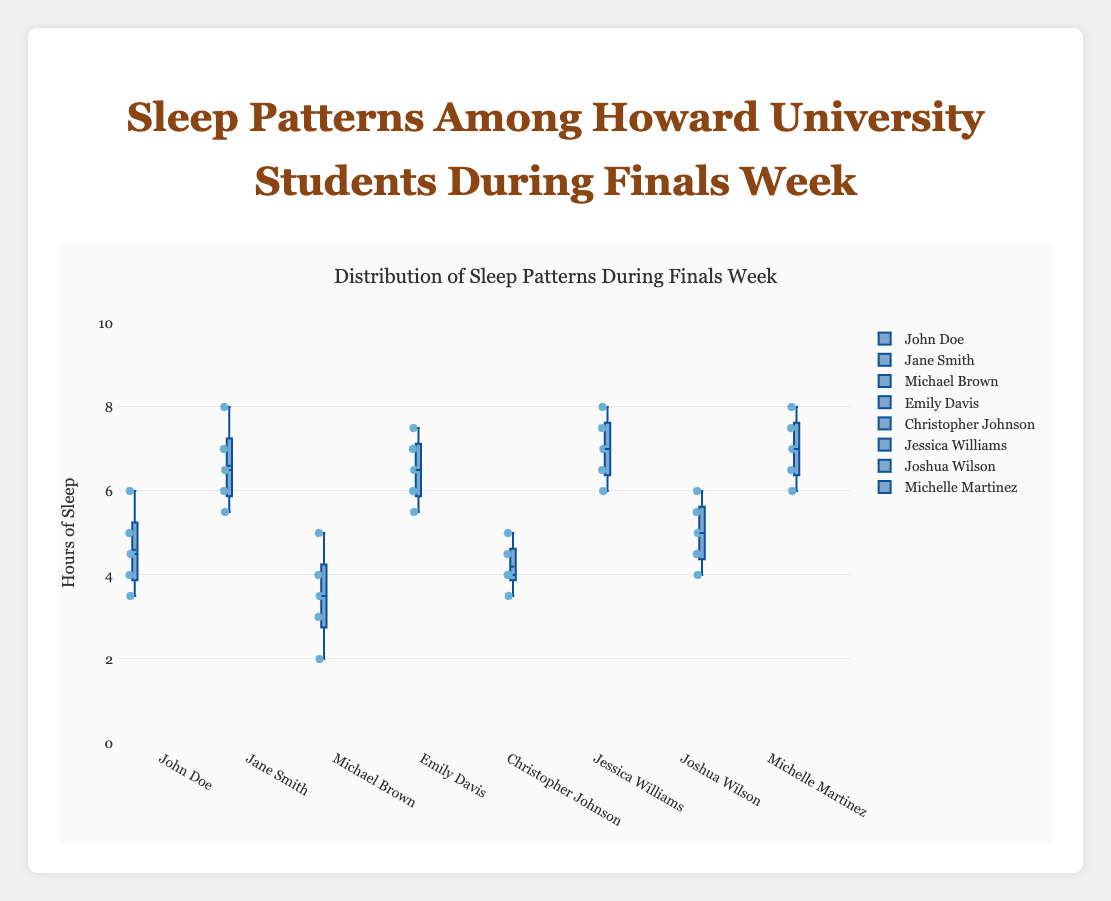What's the title of the box plot? The title is located at the top of the plot and is typically the largest text, central to the visualization.
Answer: Sleep Patterns Among Howard University Students During Finals Week What does the y-axis represent in the box plot? The y-axis label is directly stated in the plot and is typically a descriptive term that indicates what each axis measures.
Answer: Hours of Sleep Among the students, who seems to have the most consistent sleep pattern? This is determined by looking for the student with the smallest interquartile range (IQR) in their box plot, indicating less variability in their hours of sleep. Emily Davis has the smallest IQR.
Answer: Emily Davis Which student had the lowest recorded value of hours of sleep during finals week? This is determined by identifying the lowest point among all the box plots, which corresponds to the lowest recorded hours of sleep. Michael Brown has the lowest recorded value at 2 hours.
Answer: Michael Brown What is the median value of hours of sleep for Jane Smith? The median value is marked by the line inside the box of Jane Smith's box plot.
Answer: 6.5 Which student has the highest variability in their sleep pattern? This is found by identifying the student with the largest interquartile range (IQR) in their box plot. Michael Brown has the highest variability.
Answer: Michael Brown How does the sleep pattern of Jessica Williams compare to that of Michelle Martinez? By comparing the box plots, we can see variability, medians, and ranges. Both students have high median values, but Michelle Martinez has slightly higher and less variability.
Answer: Michelle Martinez has higher and less variable sleep Which students' median sleep hours fall between 4 and 6 hours? This involves checking which students' box plots' medians (indicated by the line within the box) fall between the values of 4 and 6 hours. John Doe, Christopher Johnson, and Joshua Wilson fall into this category.
Answer: John Doe, Christopher Johnson, Joshua Wilson What is the interquartile range (IQR) of sleep hours for Emily Davis? The IQR is calculated by subtracting the first quartile (lower boundary of the box) from the third quartile (upper boundary of the box). Emily Davis's IQR is 7.5 - 6.0 = 1.5.
Answer: 1.5 Can you identify any outliers in the sleep data? Outliers are often indicated by individual points outside the whiskers of the box plot. Jane Smith has one outlier at 8 hours, and Michael Brown has one at 2 hours.
Answer: Jane Smith, Michael Brown 